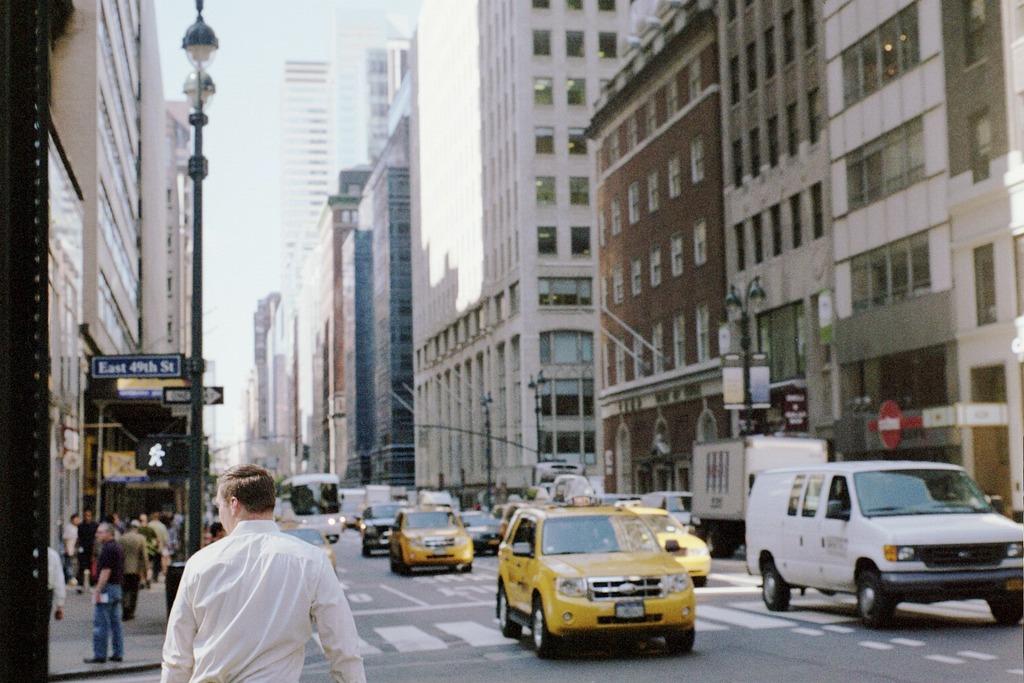What street are they on?
Make the answer very short. East 49th street. Is this a two-way street?
Offer a very short reply. No. 